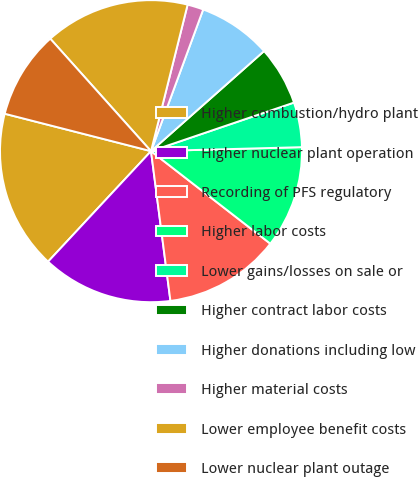Convert chart to OTSL. <chart><loc_0><loc_0><loc_500><loc_500><pie_chart><fcel>Higher combustion/hydro plant<fcel>Higher nuclear plant operation<fcel>Recording of PFS regulatory<fcel>Higher labor costs<fcel>Lower gains/losses on sale or<fcel>Higher contract labor costs<fcel>Higher donations including low<fcel>Higher material costs<fcel>Lower employee benefit costs<fcel>Lower nuclear plant outage<nl><fcel>17.05%<fcel>13.99%<fcel>12.45%<fcel>10.92%<fcel>4.79%<fcel>6.32%<fcel>7.85%<fcel>1.72%<fcel>15.52%<fcel>9.39%<nl></chart> 